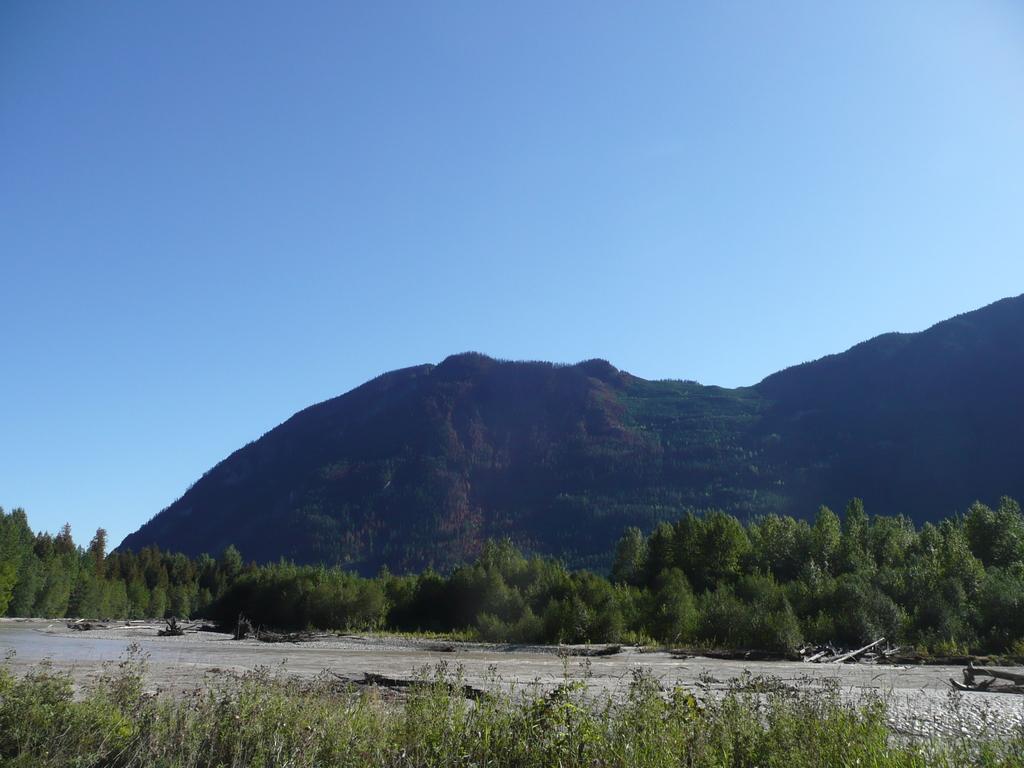Could you give a brief overview of what you see in this image? In this image there are trees, mountain, blue sky, plants and objects.   